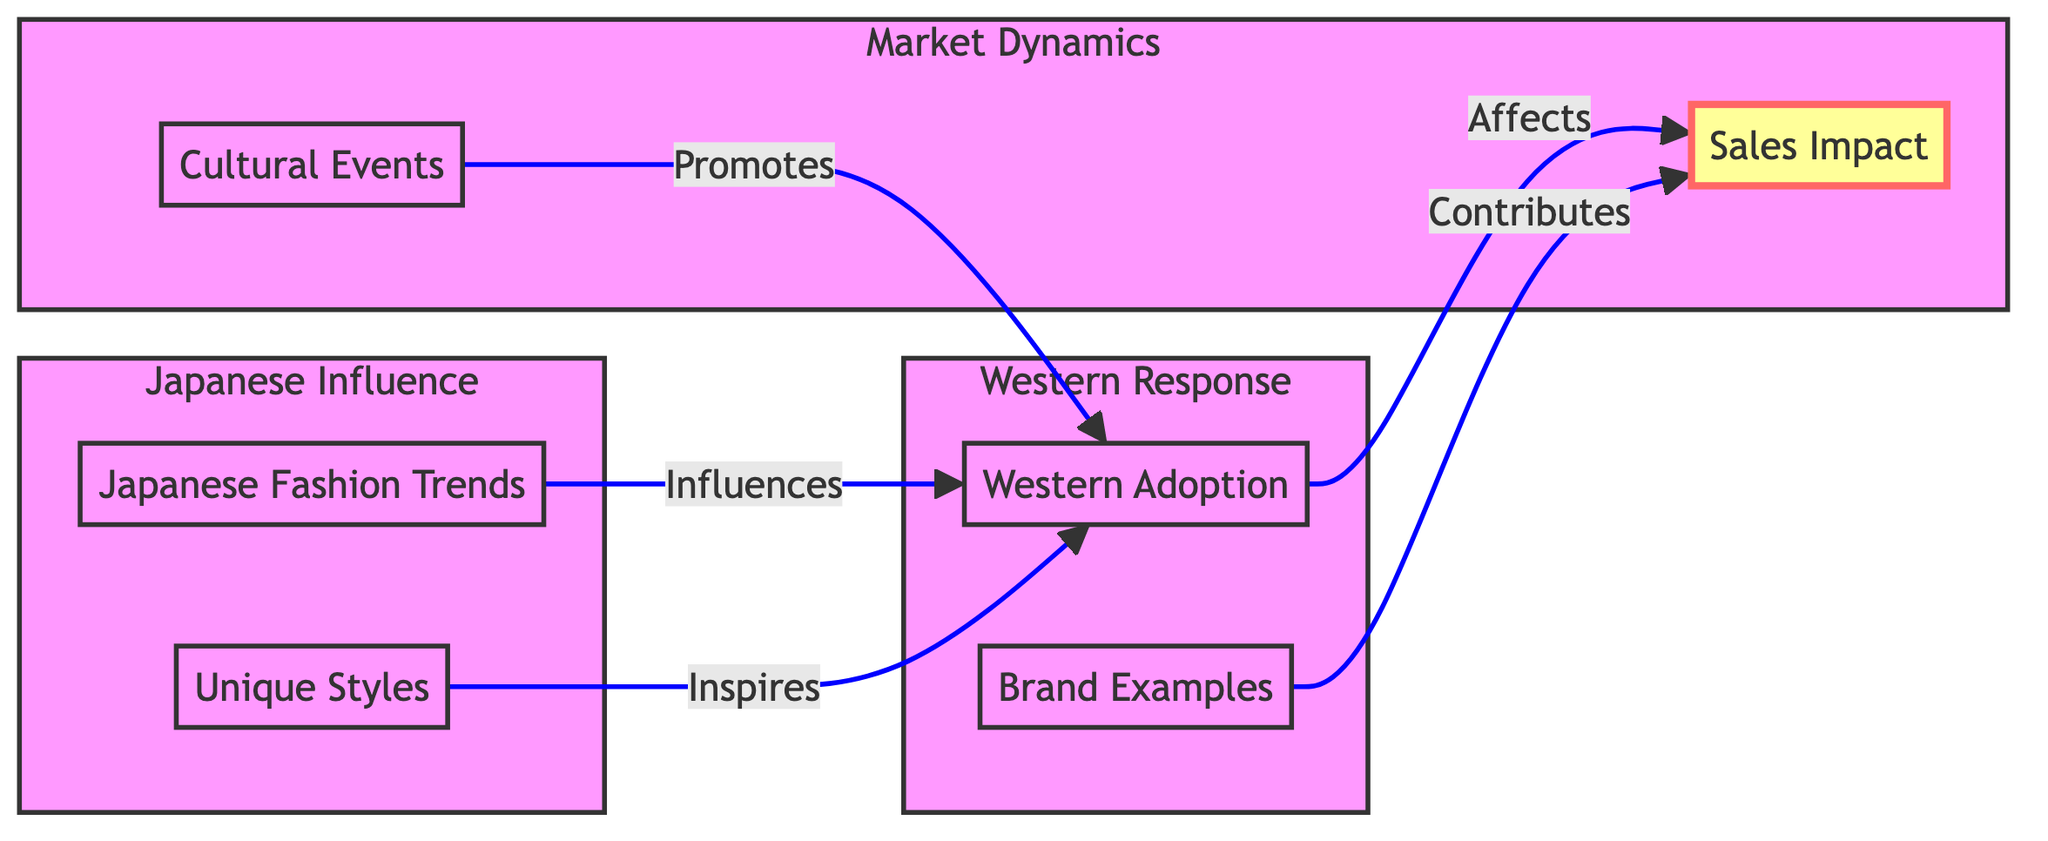What is the first node in the diagram? The first node in the diagram is Japanese Fashion Trends, which is represented as JT in the flowchart.
Answer: Japanese Fashion Trends How many nodes are in the subgraph Japanese Influence? The subgraph Japanese Influence consists of two nodes: Japanese Fashion Trends and Unique Styles.
Answer: 2 What does Western Adoption affect? Western Adoption directly influences Sales Impact, as shown by the arrow pointing from WA to SI in the diagram.
Answer: Sales Impact Which node contributes to Sales Impact? The node that contributes to Sales Impact is Brand Examples, indicated by the arrow from BE to SI.
Answer: Brand Examples How do Cultural Events relate to Western Adoption? Cultural Events promote Western Adoption, as evidenced by the arrow connecting CE to WA in the diagram.
Answer: Promotes What is the relationship between Unique Styles and Western Adoption? Unique Styles inspire Western Adoption, denoted by the arrow from US to WA.
Answer: Inspires How many total relationships (edges) are in the diagram? The diagram includes five directed edges that show the relationships between the nodes.
Answer: 5 Which subgraph contains Sales Impact? The subgraph Market Dynamics contains Sales Impact, along with Cultural Events, shown distinctly in the diagram.
Answer: Market Dynamics What impact does Japanese Fashion Trends have on the diagram? Japanese Fashion Trends influences Western Adoption, as depicted by the connecting arrow from JT to WA.
Answer: Influences 